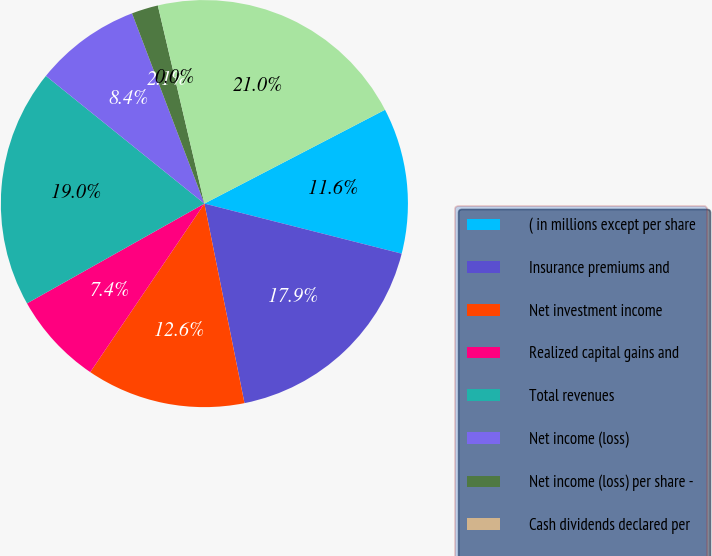<chart> <loc_0><loc_0><loc_500><loc_500><pie_chart><fcel>( in millions except per share<fcel>Insurance premiums and<fcel>Net investment income<fcel>Realized capital gains and<fcel>Total revenues<fcel>Net income (loss)<fcel>Net income (loss) per share -<fcel>Cash dividends declared per<fcel>Investments<nl><fcel>11.58%<fcel>17.89%<fcel>12.63%<fcel>7.37%<fcel>18.95%<fcel>8.42%<fcel>2.11%<fcel>0.0%<fcel>21.05%<nl></chart> 